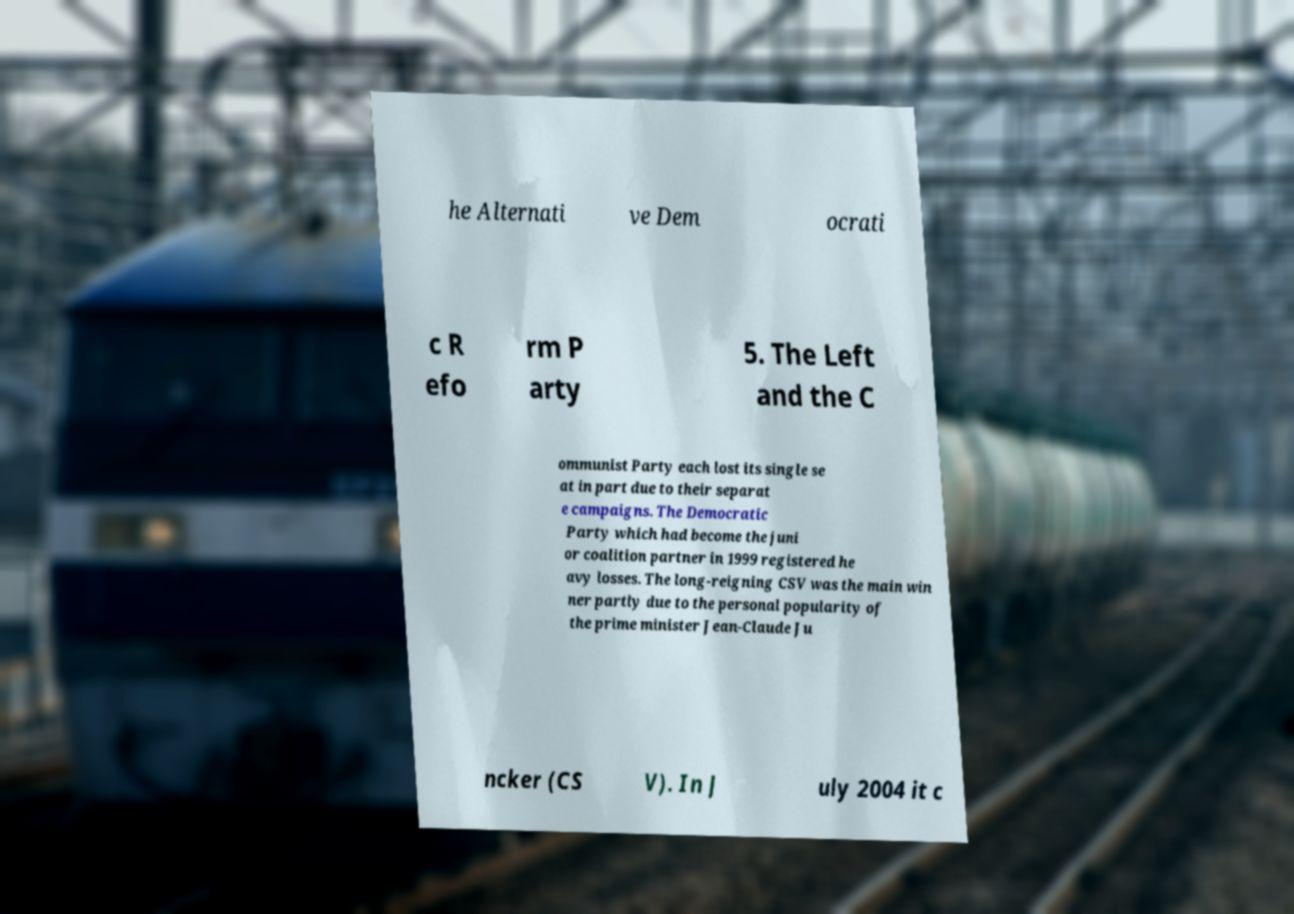Can you read and provide the text displayed in the image?This photo seems to have some interesting text. Can you extract and type it out for me? he Alternati ve Dem ocrati c R efo rm P arty 5. The Left and the C ommunist Party each lost its single se at in part due to their separat e campaigns. The Democratic Party which had become the juni or coalition partner in 1999 registered he avy losses. The long-reigning CSV was the main win ner partly due to the personal popularity of the prime minister Jean-Claude Ju ncker (CS V). In J uly 2004 it c 